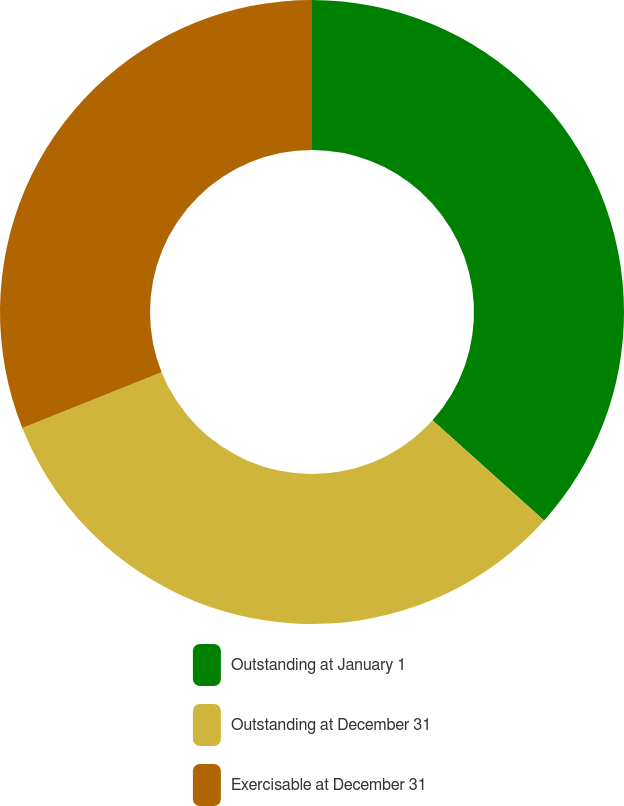<chart> <loc_0><loc_0><loc_500><loc_500><pie_chart><fcel>Outstanding at January 1<fcel>Outstanding at December 31<fcel>Exercisable at December 31<nl><fcel>36.65%<fcel>32.3%<fcel>31.06%<nl></chart> 